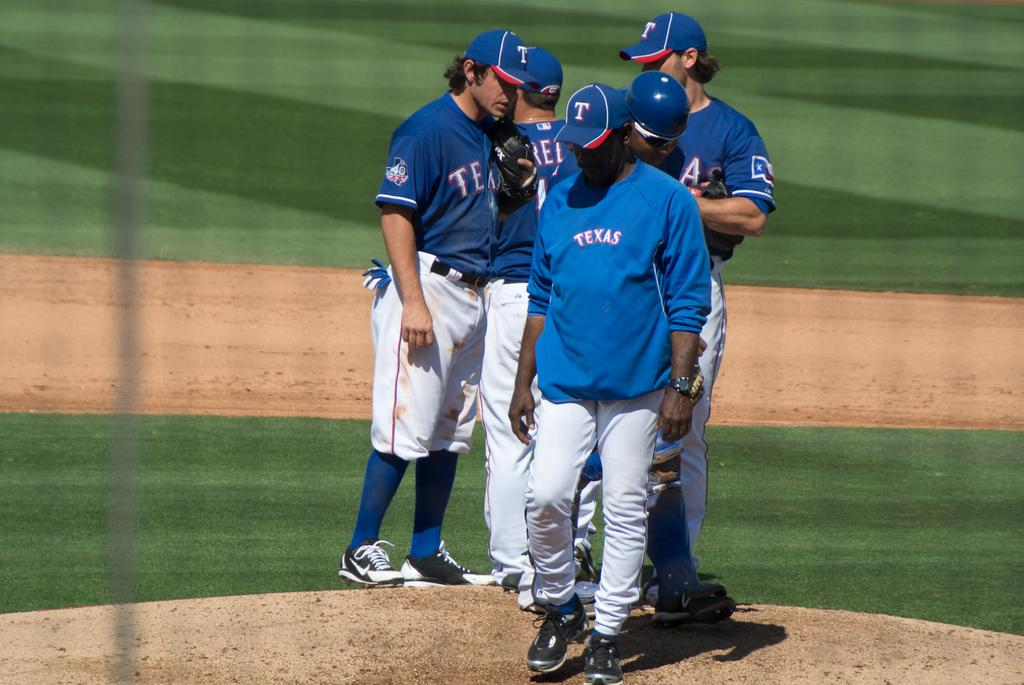<image>
Relay a brief, clear account of the picture shown. Several men on a sports field, their shirts have Texas on them. 